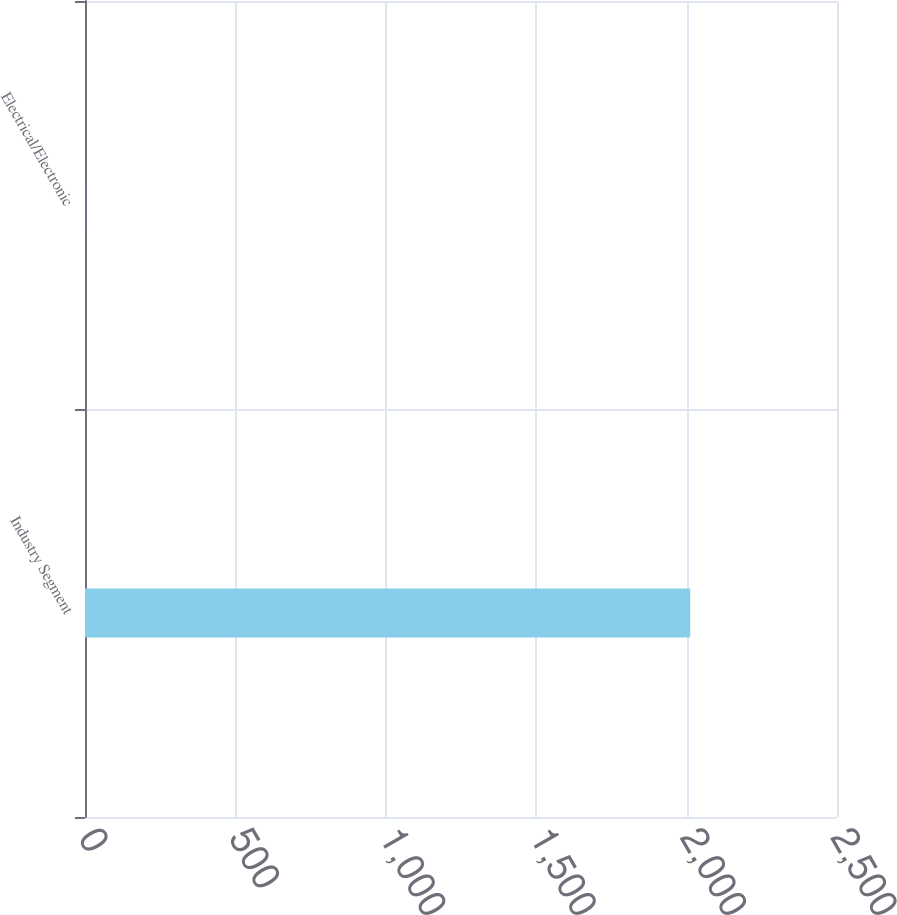Convert chart to OTSL. <chart><loc_0><loc_0><loc_500><loc_500><bar_chart><fcel>Industry Segment<fcel>Electrical/Electronic<nl><fcel>2012<fcel>4<nl></chart> 